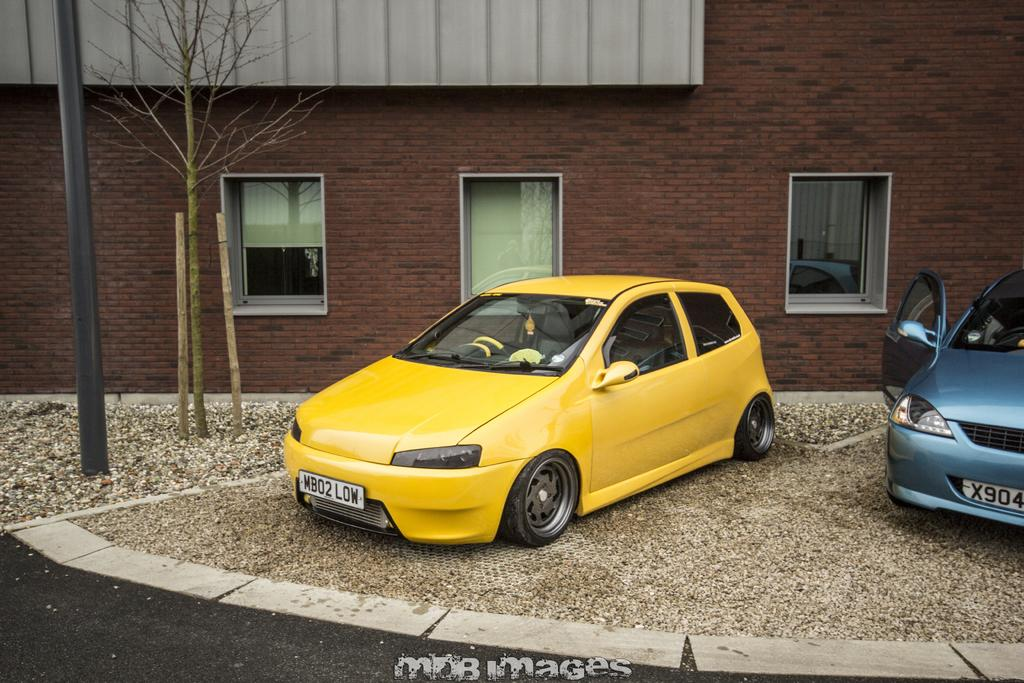How many cars are visible in the image? There are two cars in the image. What is the status of the cars in the image? The cars are parked. What are the colors of the cars in the image? The cars are in different colors. What can be seen in the background of the image? There is a wall, windows, and a tree in the background of the image. Can you see a clover growing between the two cars in the image? There is no clover visible between the two cars in the image. 